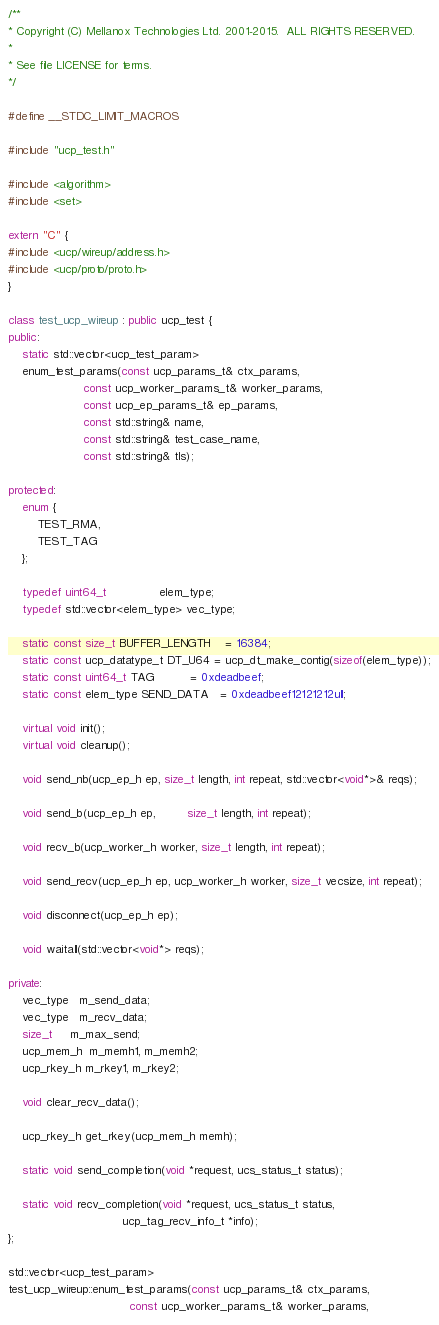Convert code to text. <code><loc_0><loc_0><loc_500><loc_500><_C++_>/**
* Copyright (C) Mellanox Technologies Ltd. 2001-2015.  ALL RIGHTS RESERVED.
*
* See file LICENSE for terms.
*/

#define __STDC_LIMIT_MACROS

#include "ucp_test.h"

#include <algorithm>
#include <set>

extern "C" {
#include <ucp/wireup/address.h>
#include <ucp/proto/proto.h>
}

class test_ucp_wireup : public ucp_test {
public:
    static std::vector<ucp_test_param>
    enum_test_params(const ucp_params_t& ctx_params,
                     const ucp_worker_params_t& worker_params,
                     const ucp_ep_params_t& ep_params,
                     const std::string& name,
                     const std::string& test_case_name,
                     const std::string& tls);

protected:
    enum {
        TEST_RMA,
        TEST_TAG
    };

    typedef uint64_t               elem_type;
    typedef std::vector<elem_type> vec_type;

    static const size_t BUFFER_LENGTH    = 16384;
    static const ucp_datatype_t DT_U64 = ucp_dt_make_contig(sizeof(elem_type));
    static const uint64_t TAG          = 0xdeadbeef;
    static const elem_type SEND_DATA   = 0xdeadbeef12121212ull;

    virtual void init();
    virtual void cleanup();

    void send_nb(ucp_ep_h ep, size_t length, int repeat, std::vector<void*>& reqs);

    void send_b(ucp_ep_h ep,         size_t length, int repeat);

    void recv_b(ucp_worker_h worker, size_t length, int repeat);

    void send_recv(ucp_ep_h ep, ucp_worker_h worker, size_t vecsize, int repeat);

    void disconnect(ucp_ep_h ep);

    void waitall(std::vector<void*> reqs);

private:
    vec_type   m_send_data;
    vec_type   m_recv_data;
    size_t     m_max_send;
    ucp_mem_h  m_memh1, m_memh2;
    ucp_rkey_h m_rkey1, m_rkey2;

    void clear_recv_data();

    ucp_rkey_h get_rkey(ucp_mem_h memh);

    static void send_completion(void *request, ucs_status_t status);

    static void recv_completion(void *request, ucs_status_t status,
                                ucp_tag_recv_info_t *info);
};

std::vector<ucp_test_param>
test_ucp_wireup::enum_test_params(const ucp_params_t& ctx_params,
                                  const ucp_worker_params_t& worker_params,</code> 